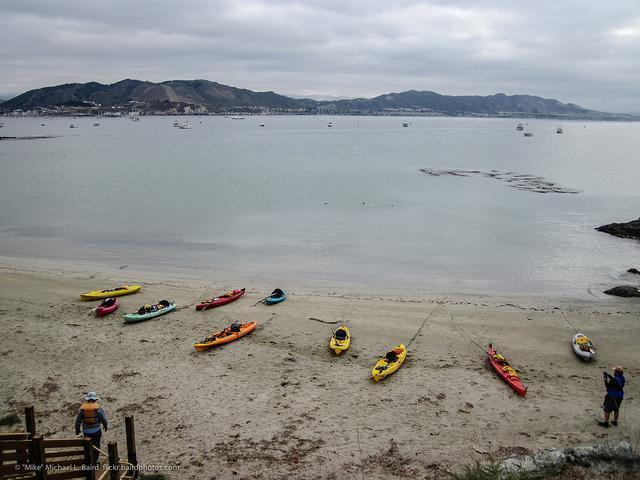What method do these vessels shown here normally gain movement?
Indicate the correct choice and explain in the format: 'Answer: answer
Rationale: rationale.'
Options: Motors, wind, none, oars. Answer: oars.
Rationale: Kayaks are lined up in the sand on a beach. kayaks are propelled by a person paddling. 